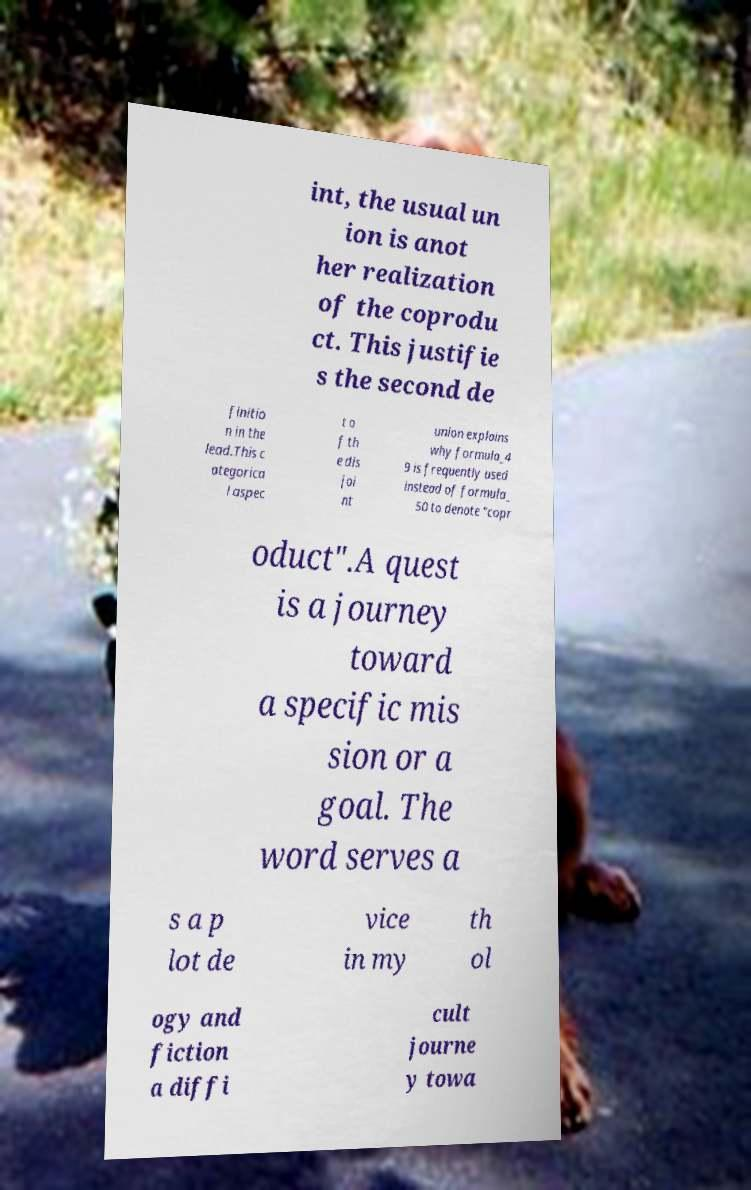Could you extract and type out the text from this image? int, the usual un ion is anot her realization of the coprodu ct. This justifie s the second de finitio n in the lead.This c ategorica l aspec t o f th e dis joi nt union explains why formula_4 9 is frequently used instead of formula_ 50 to denote "copr oduct".A quest is a journey toward a specific mis sion or a goal. The word serves a s a p lot de vice in my th ol ogy and fiction a diffi cult journe y towa 